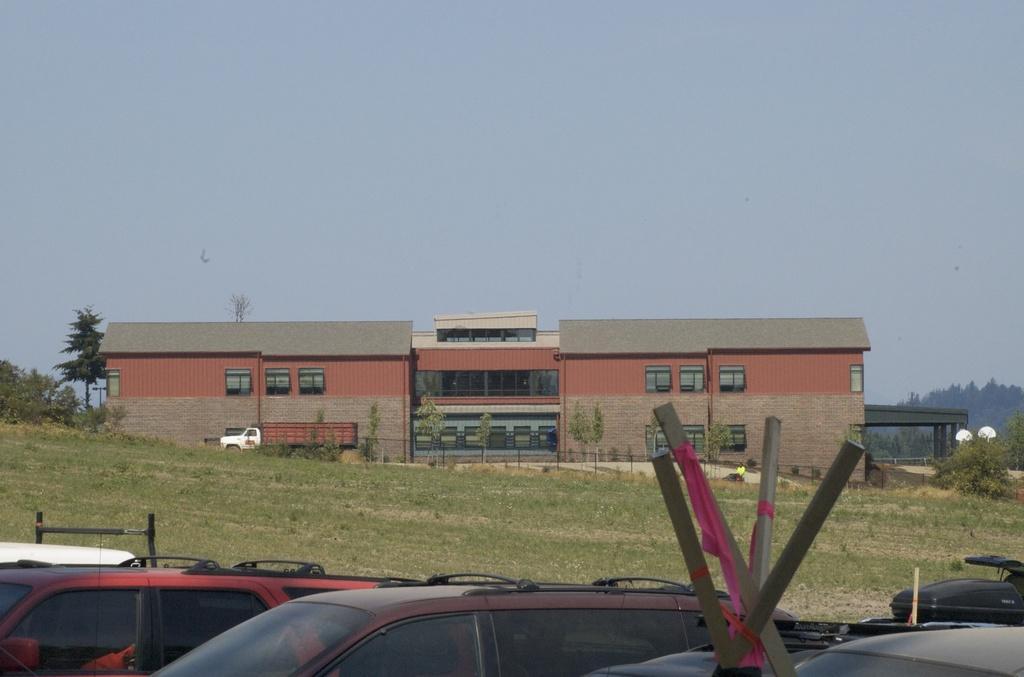In one or two sentences, can you explain what this image depicts? In this image few vehicles and I see the grass. In the background I see a building and I see few trees and I see the sky. 